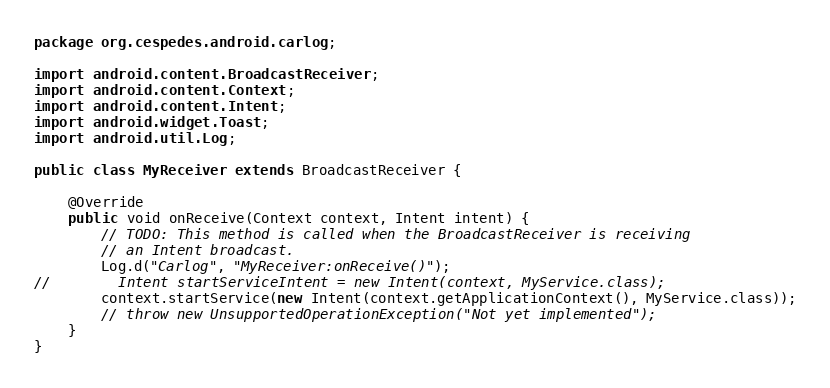Convert code to text. <code><loc_0><loc_0><loc_500><loc_500><_Java_>package org.cespedes.android.carlog;

import android.content.BroadcastReceiver;
import android.content.Context;
import android.content.Intent;
import android.widget.Toast;
import android.util.Log;

public class MyReceiver extends BroadcastReceiver {

    @Override
    public void onReceive(Context context, Intent intent) {
        // TODO: This method is called when the BroadcastReceiver is receiving
        // an Intent broadcast.
        Log.d("Carlog", "MyReceiver:onReceive()");
//        Intent startServiceIntent = new Intent(context, MyService.class);
        context.startService(new Intent(context.getApplicationContext(), MyService.class));
        // throw new UnsupportedOperationException("Not yet implemented");
    }
}
</code> 